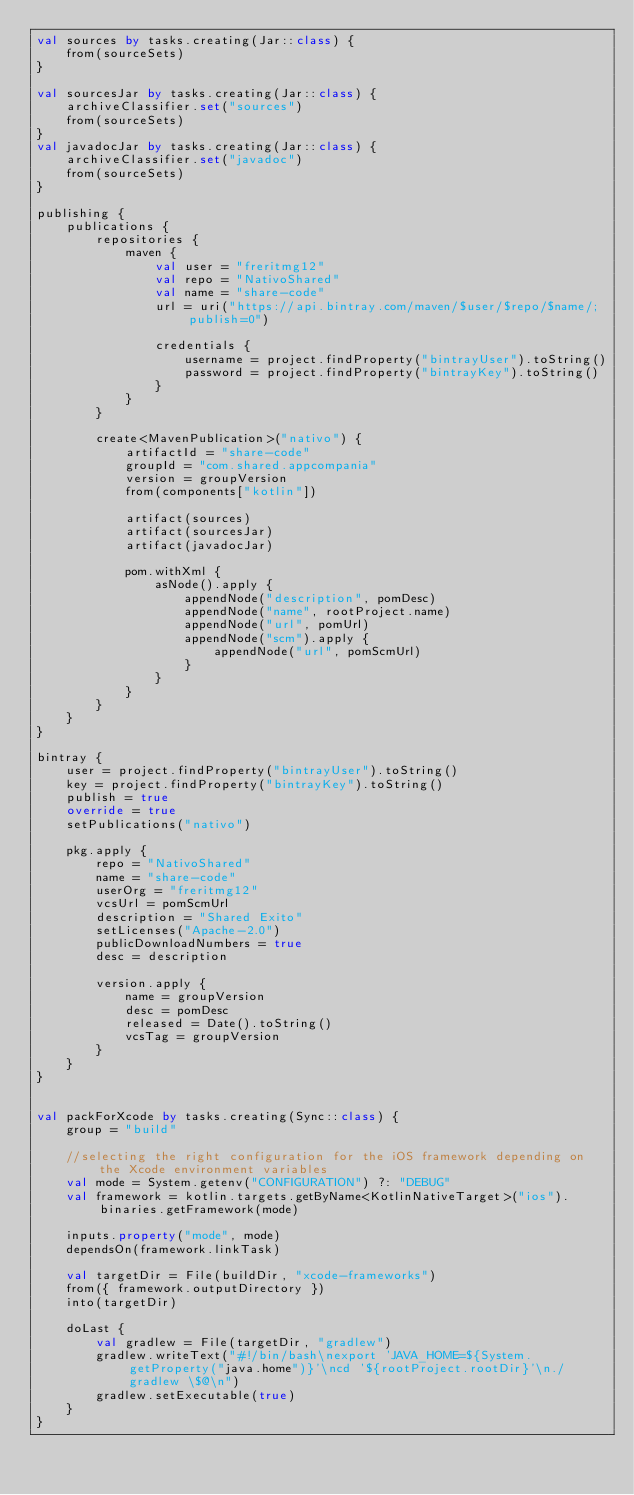Convert code to text. <code><loc_0><loc_0><loc_500><loc_500><_Kotlin_>val sources by tasks.creating(Jar::class) {
    from(sourceSets)
}

val sourcesJar by tasks.creating(Jar::class) {
    archiveClassifier.set("sources")
    from(sourceSets)
}
val javadocJar by tasks.creating(Jar::class) {
    archiveClassifier.set("javadoc")
    from(sourceSets)
}

publishing {
    publications {
        repositories {
            maven {
                val user = "freritmg12"
                val repo = "NativoShared"
                val name = "share-code"
                url = uri("https://api.bintray.com/maven/$user/$repo/$name/;publish=0")

                credentials {
                    username = project.findProperty("bintrayUser").toString()
                    password = project.findProperty("bintrayKey").toString()
                }
            }
        }

        create<MavenPublication>("nativo") {
            artifactId = "share-code"
            groupId = "com.shared.appcompania"
            version = groupVersion
            from(components["kotlin"])

            artifact(sources)
            artifact(sourcesJar)
            artifact(javadocJar)

            pom.withXml {
                asNode().apply {
                    appendNode("description", pomDesc)
                    appendNode("name", rootProject.name)
                    appendNode("url", pomUrl)
                    appendNode("scm").apply {
                        appendNode("url", pomScmUrl)
                    }
                }
            }
        }
    }
}

bintray {
    user = project.findProperty("bintrayUser").toString()
    key = project.findProperty("bintrayKey").toString()
    publish = true
    override = true
    setPublications("nativo")

    pkg.apply {
        repo = "NativoShared"
        name = "share-code"
        userOrg = "freritmg12"
        vcsUrl = pomScmUrl
        description = "Shared Exito"
        setLicenses("Apache-2.0")
        publicDownloadNumbers = true
        desc = description

        version.apply {
            name = groupVersion
            desc = pomDesc
            released = Date().toString()
            vcsTag = groupVersion
        }
    }
}


val packForXcode by tasks.creating(Sync::class) {
    group = "build"

    //selecting the right configuration for the iOS framework depending on the Xcode environment variables
    val mode = System.getenv("CONFIGURATION") ?: "DEBUG"
    val framework = kotlin.targets.getByName<KotlinNativeTarget>("ios").binaries.getFramework(mode)

    inputs.property("mode", mode)
    dependsOn(framework.linkTask)

    val targetDir = File(buildDir, "xcode-frameworks")
    from({ framework.outputDirectory })
    into(targetDir)

    doLast {
        val gradlew = File(targetDir, "gradlew")
        gradlew.writeText("#!/bin/bash\nexport 'JAVA_HOME=${System.getProperty("java.home")}'\ncd '${rootProject.rootDir}'\n./gradlew \$@\n")
        gradlew.setExecutable(true)
    }
}
</code> 